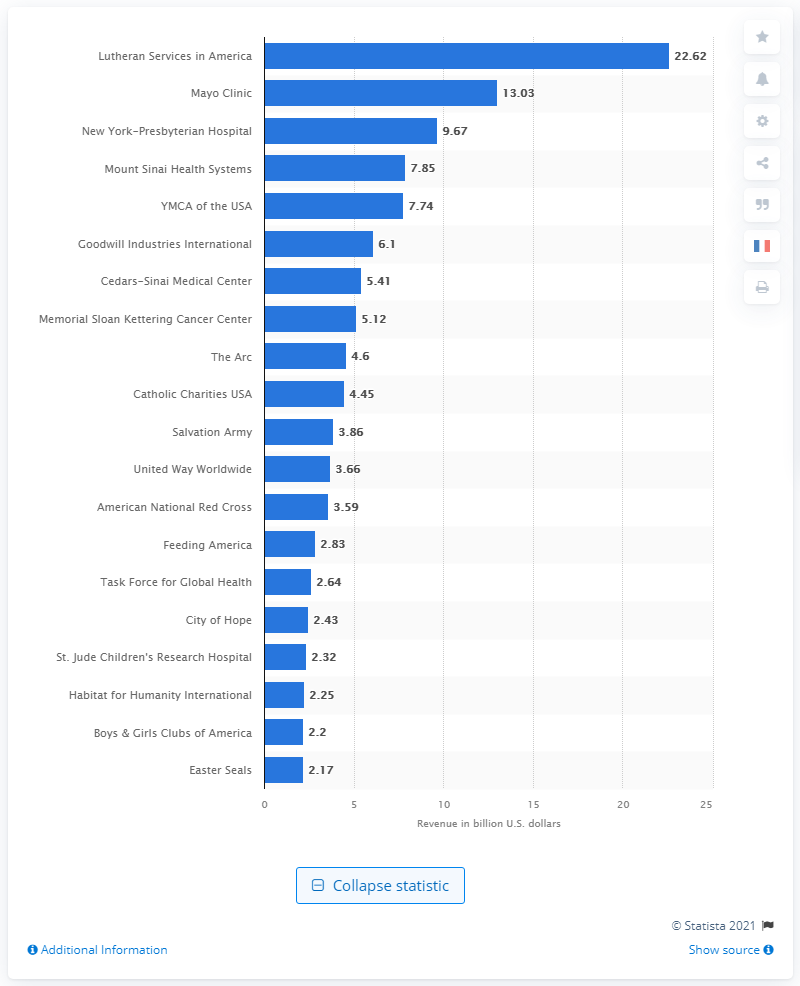Indicate a few pertinent items in this graphic. In 2019, the total revenue of Lutheran Services in America was $22.62 million. 